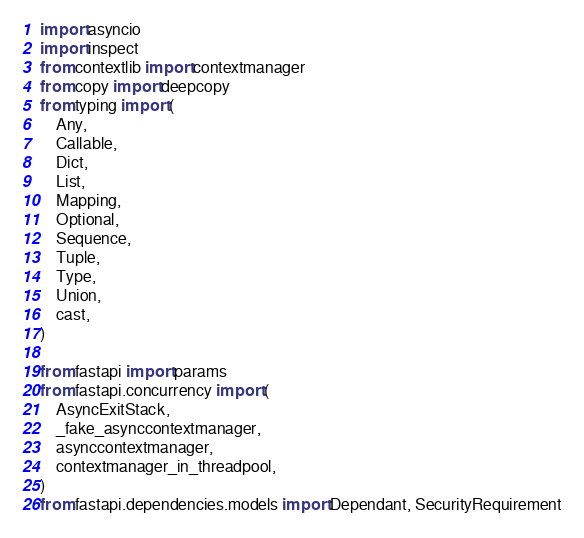Convert code to text. <code><loc_0><loc_0><loc_500><loc_500><_Python_>import asyncio
import inspect
from contextlib import contextmanager
from copy import deepcopy
from typing import (
    Any,
    Callable,
    Dict,
    List,
    Mapping,
    Optional,
    Sequence,
    Tuple,
    Type,
    Union,
    cast,
)

from fastapi import params
from fastapi.concurrency import (
    AsyncExitStack,
    _fake_asynccontextmanager,
    asynccontextmanager,
    contextmanager_in_threadpool,
)
from fastapi.dependencies.models import Dependant, SecurityRequirement</code> 